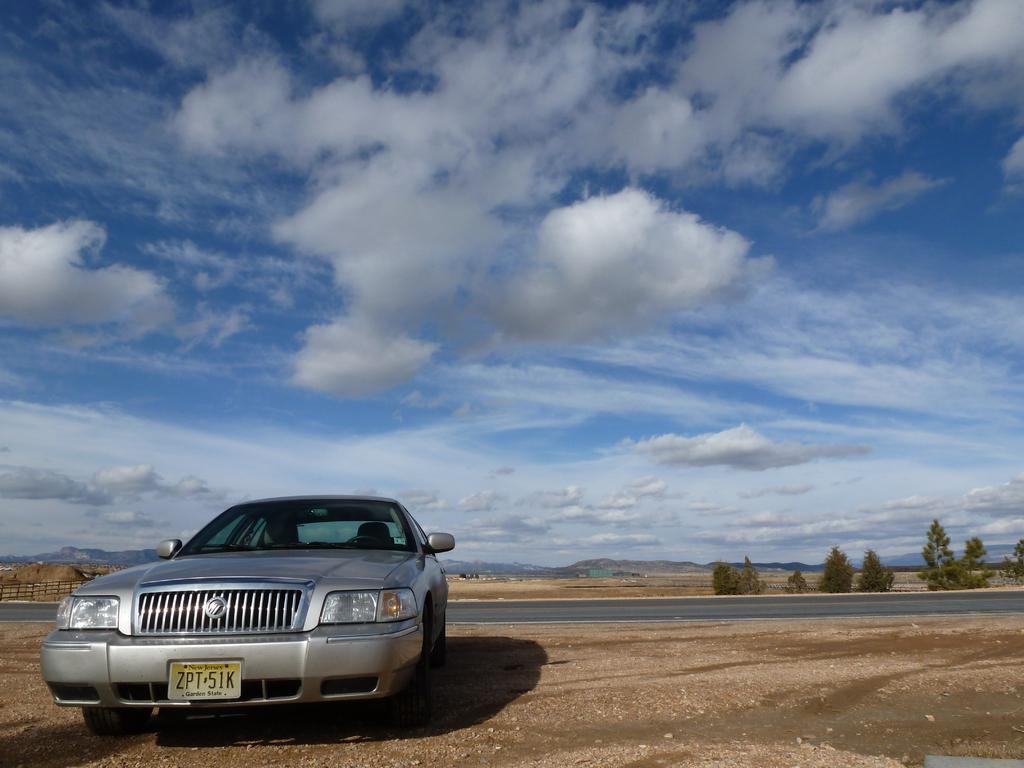Could you give a brief overview of what you see in this image? In this picture, we see a car, which is parked. At the bottom of the picture, we see the soil and the stones. In the middle of the picture, we see the road. There are trees and hills in the background. On the left side, we see a wooden railing. At the top of the picture, we see the sky and the clouds. 